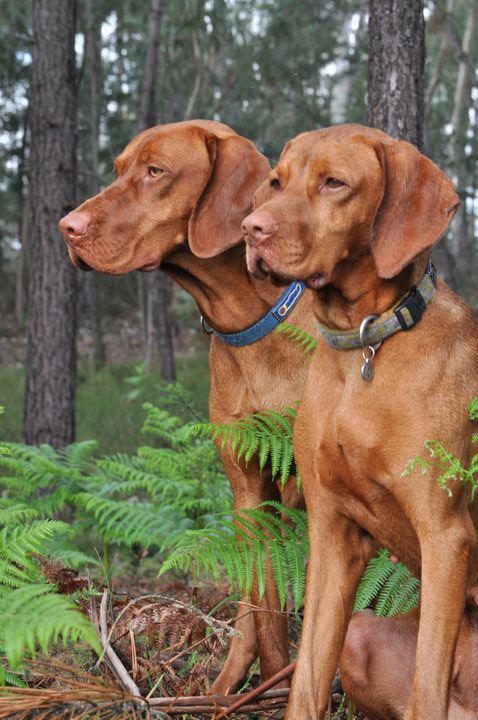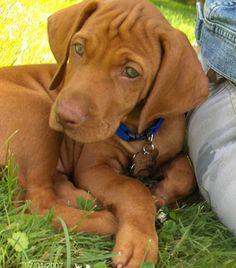The first image is the image on the left, the second image is the image on the right. Examine the images to the left and right. Is the description "There are two dogs in one image and one dog in the other image." accurate? Answer yes or no. Yes. The first image is the image on the left, the second image is the image on the right. Considering the images on both sides, is "One dog's forehead is scrunched up." valid? Answer yes or no. Yes. 